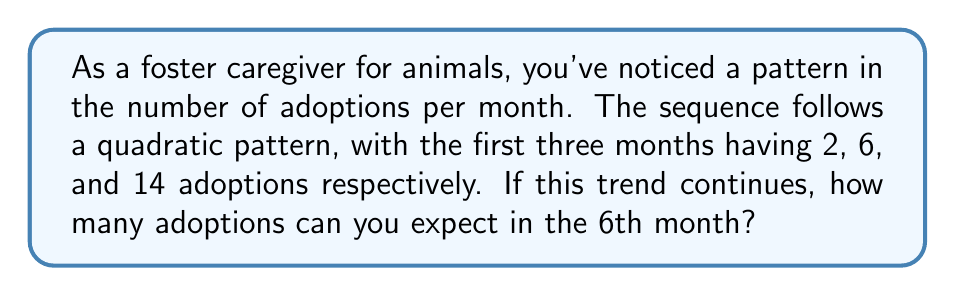Give your solution to this math problem. Let's approach this step-by-step:

1) In a quadratic sequence, the second difference is constant. Let's find the differences:

   Month 1: 2
   Month 2: 6   First difference: 6 - 2 = 4
   Month 3: 14  First difference: 14 - 6 = 8
               Second difference: 8 - 4 = 4

2) The general form of a quadratic sequence is:
   $$a_n = an^2 + bn + c$$
   where $n$ is the term number (month in this case).

3) We need to find $a$, $b$, and $c$. We know that the second difference is constant and equals $2a$. So:
   $$2a = 4$$
   $$a = 2$$

4) Now we can set up three equations using the first three terms:
   $$2 = a(1)^2 + b(1) + c$$
   $$6 = a(2)^2 + b(2) + c$$
   $$14 = a(3)^2 + b(3) + c$$

5) Substituting $a = 2$ and solving these equations:
   $$2 = 2 + b + c$$
   $$6 = 8 + 2b + c$$
   $$14 = 18 + 3b + c$$

6) From the first equation:
   $$c = -b$$

7) Substituting this into the second equation:
   $$6 = 8 + 2b - b$$
   $$6 = 8 + b$$
   $$b = -2$$

8) Therefore, $c = 2$

9) Our quadratic sequence is:
   $$a_n = 2n^2 - 2n + 2$$

10) For the 6th month, $n = 6$:
    $$a_6 = 2(6)^2 - 2(6) + 2$$
    $$a_6 = 2(36) - 12 + 2$$
    $$a_6 = 72 - 12 + 2 = 62$$
Answer: 62 adoptions 